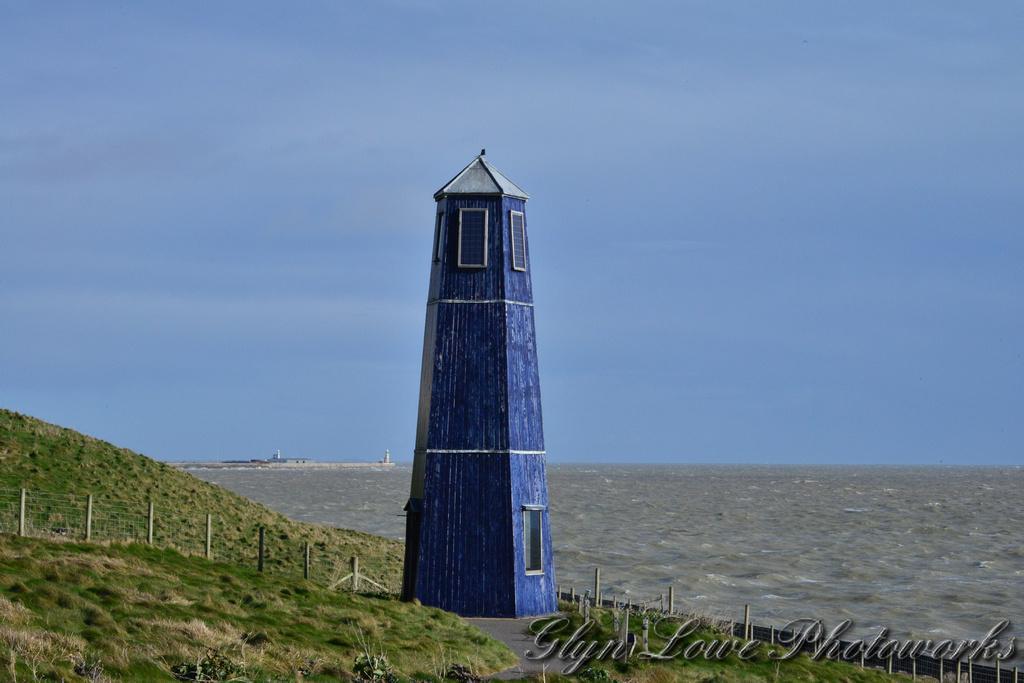Can you describe this image briefly? In this image we can see the blue color tower building. Here we can see the grass, fence, water and the blue sky in the background. Here we can see the watermark on the bottom right side of the image. 